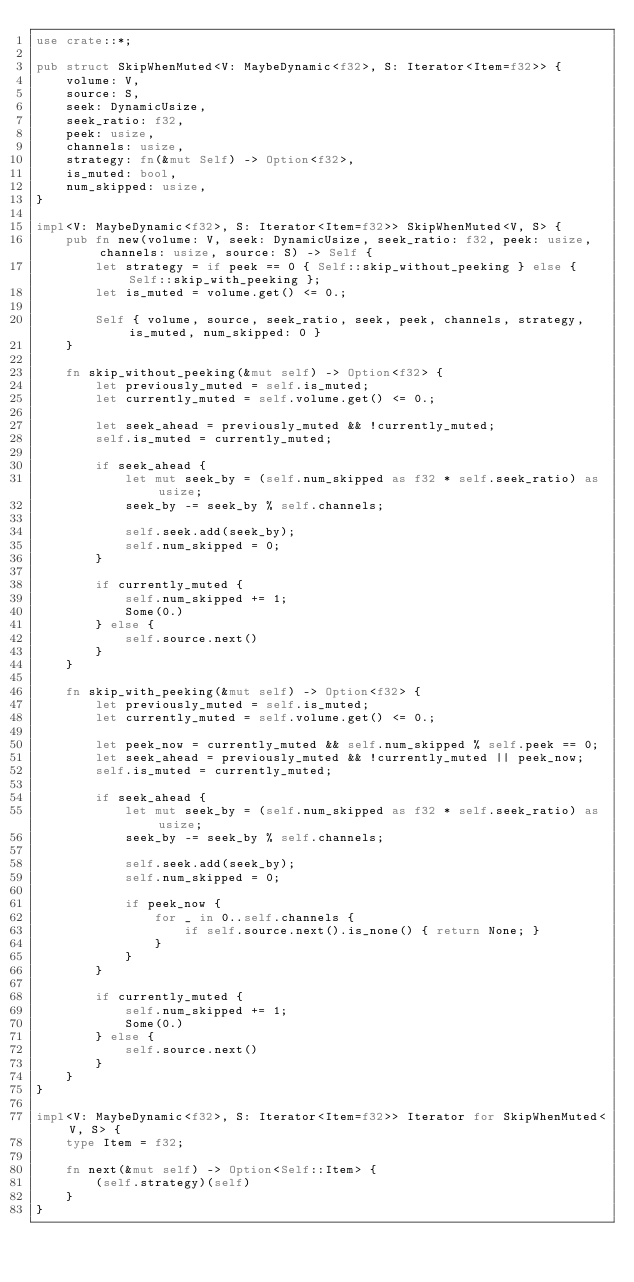Convert code to text. <code><loc_0><loc_0><loc_500><loc_500><_Rust_>use crate::*;

pub struct SkipWhenMuted<V: MaybeDynamic<f32>, S: Iterator<Item=f32>> {
    volume: V,
    source: S,
    seek: DynamicUsize,
    seek_ratio: f32,
    peek: usize,
    channels: usize,
    strategy: fn(&mut Self) -> Option<f32>,
    is_muted: bool,
    num_skipped: usize,
}

impl<V: MaybeDynamic<f32>, S: Iterator<Item=f32>> SkipWhenMuted<V, S> {
    pub fn new(volume: V, seek: DynamicUsize, seek_ratio: f32, peek: usize, channels: usize, source: S) -> Self {
        let strategy = if peek == 0 { Self::skip_without_peeking } else { Self::skip_with_peeking };
        let is_muted = volume.get() <= 0.;

        Self { volume, source, seek_ratio, seek, peek, channels, strategy, is_muted, num_skipped: 0 }
    }

    fn skip_without_peeking(&mut self) -> Option<f32> {
        let previously_muted = self.is_muted;
        let currently_muted = self.volume.get() <= 0.;

        let seek_ahead = previously_muted && !currently_muted;
        self.is_muted = currently_muted;

        if seek_ahead {
            let mut seek_by = (self.num_skipped as f32 * self.seek_ratio) as usize;
            seek_by -= seek_by % self.channels;

            self.seek.add(seek_by);
            self.num_skipped = 0;
        }

        if currently_muted {
            self.num_skipped += 1;
            Some(0.)
        } else {
            self.source.next()
        }
    }

    fn skip_with_peeking(&mut self) -> Option<f32> {
        let previously_muted = self.is_muted;
        let currently_muted = self.volume.get() <= 0.;

        let peek_now = currently_muted && self.num_skipped % self.peek == 0;
        let seek_ahead = previously_muted && !currently_muted || peek_now;
        self.is_muted = currently_muted;

        if seek_ahead {
            let mut seek_by = (self.num_skipped as f32 * self.seek_ratio) as usize;
            seek_by -= seek_by % self.channels;

            self.seek.add(seek_by);
            self.num_skipped = 0;

            if peek_now {
                for _ in 0..self.channels {
                    if self.source.next().is_none() { return None; }
                }
            }
        }

        if currently_muted {
            self.num_skipped += 1;
            Some(0.)
        } else {
            self.source.next()
        }
    }
}

impl<V: MaybeDynamic<f32>, S: Iterator<Item=f32>> Iterator for SkipWhenMuted<V, S> {
    type Item = f32;

    fn next(&mut self) -> Option<Self::Item> {
        (self.strategy)(self)
    }
}
</code> 